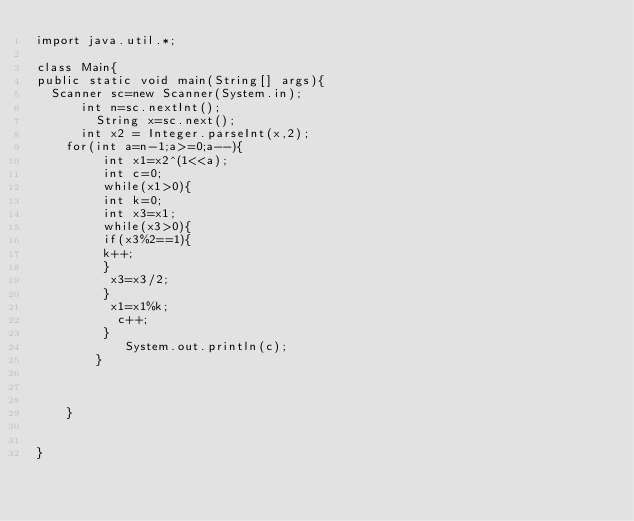<code> <loc_0><loc_0><loc_500><loc_500><_Java_>import java.util.*; 

class Main{
public static void main(String[] args){
	Scanner sc=new Scanner(System.in);
  		int n=sc.nextInt();
        String x=sc.next();
  		int x2 = Integer.parseInt(x,2);	
		for(int a=n-1;a>=0;a--){
         int x1=x2^(1<<a); 
         int c=0;
         while(x1>0){
         int k=0;
         int x3=x1;
         while(x3>0){
         if(x3%2==1){
         k++;
         }
          x3=x3/2;
         }
          x1=x1%k;
           c++;
         }
          	System.out.println(c);
        }


    
    }
 
  
}</code> 